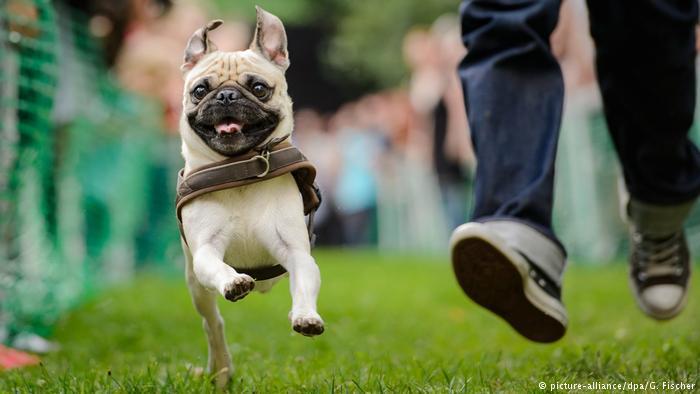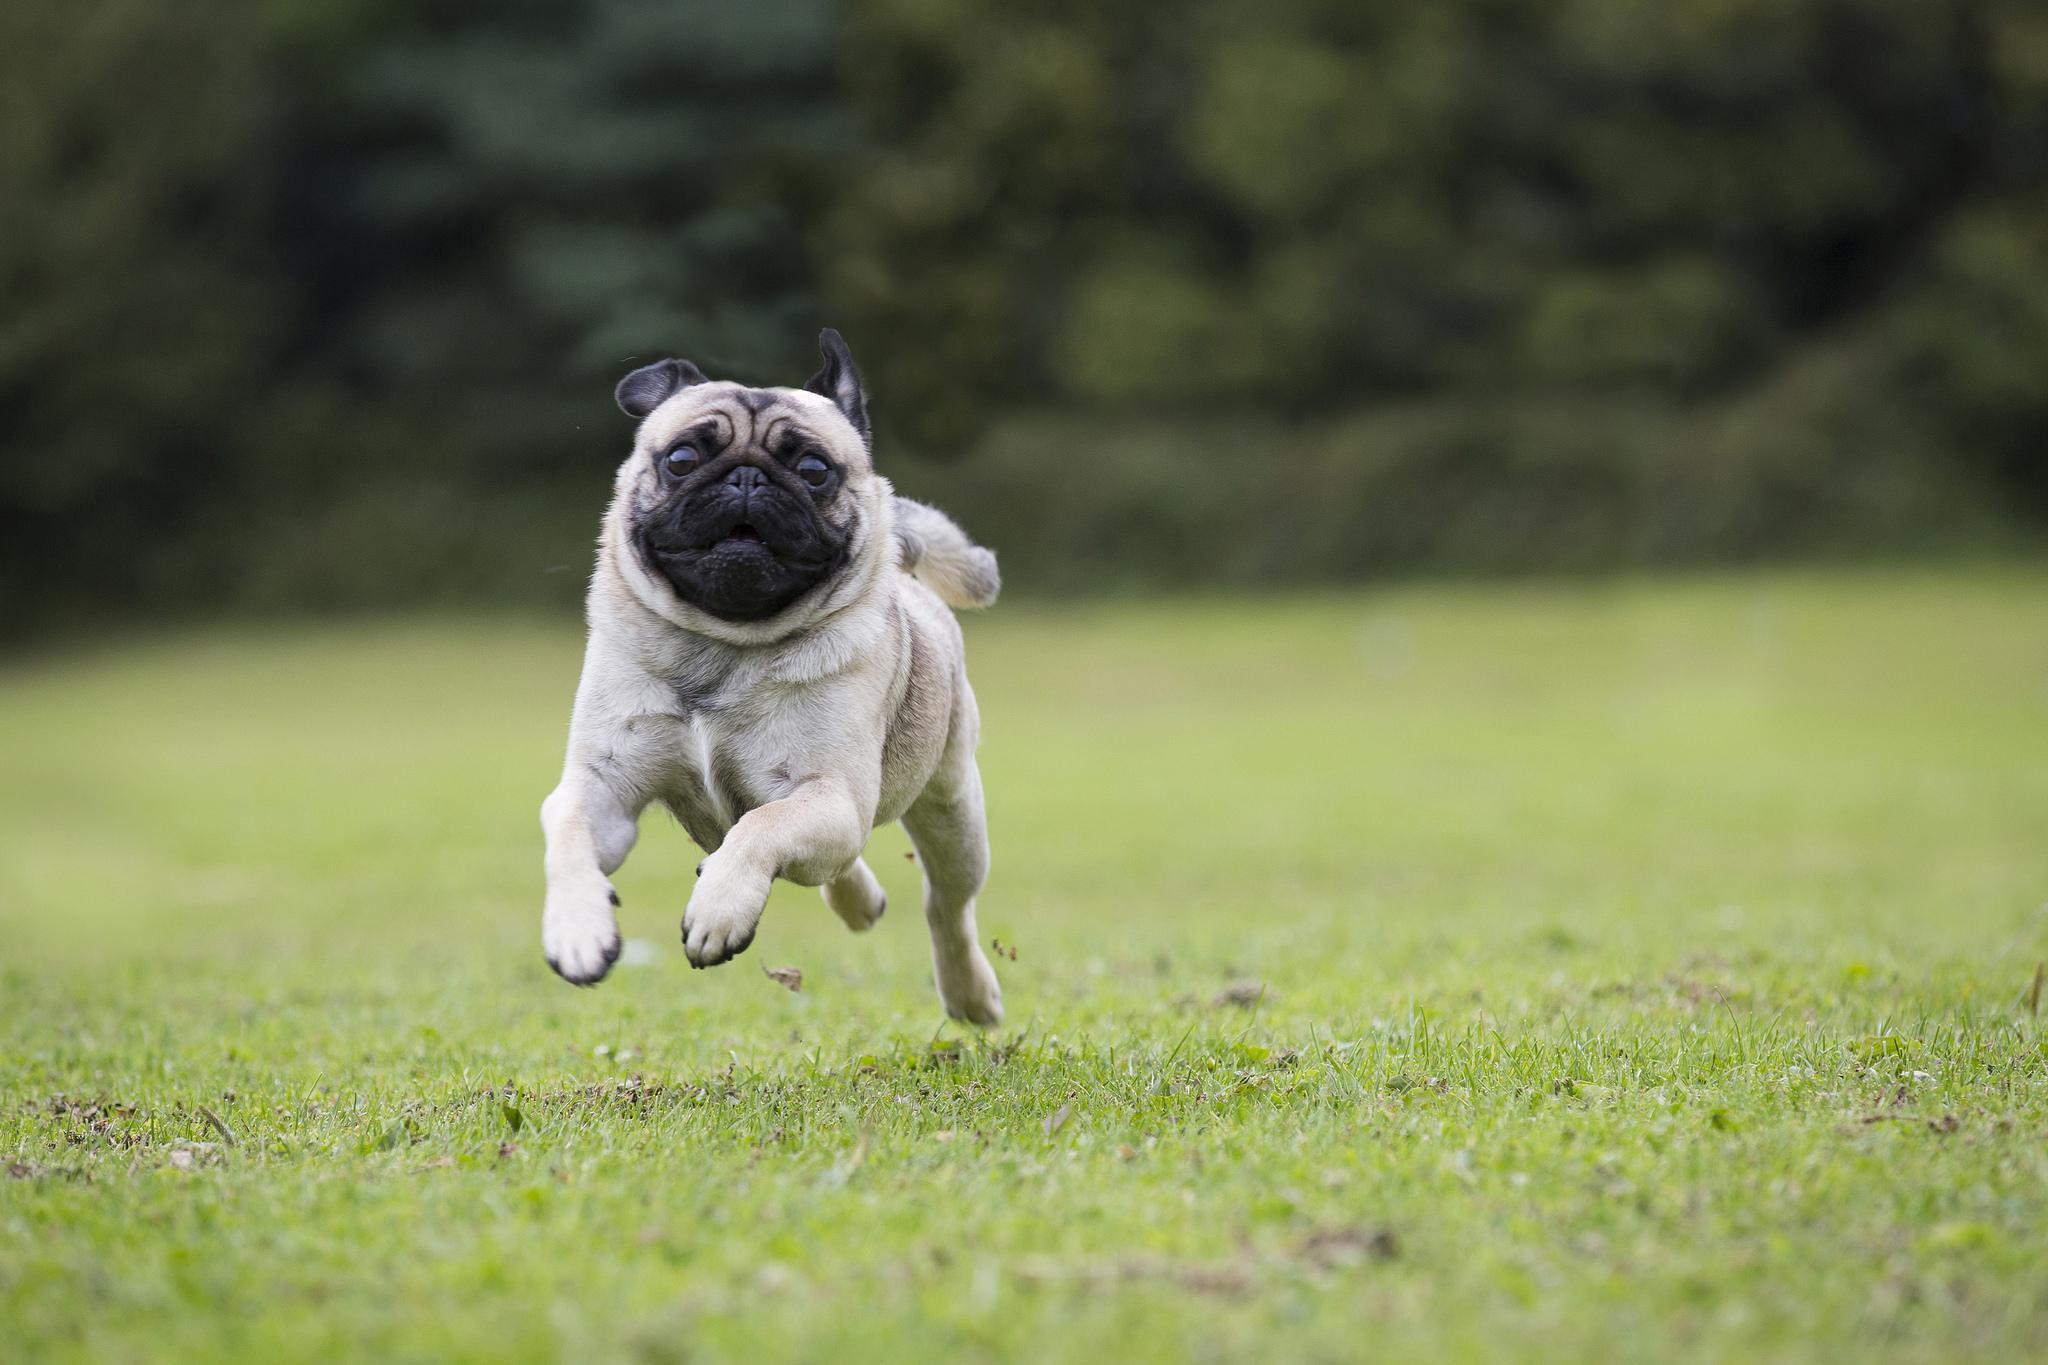The first image is the image on the left, the second image is the image on the right. Evaluate the accuracy of this statement regarding the images: "There are at least four pugs in total.". Is it true? Answer yes or no. No. The first image is the image on the left, the second image is the image on the right. Evaluate the accuracy of this statement regarding the images: "there is at least one dog in the image pair running and none of it's feet are touching the ground". Is it true? Answer yes or no. Yes. 